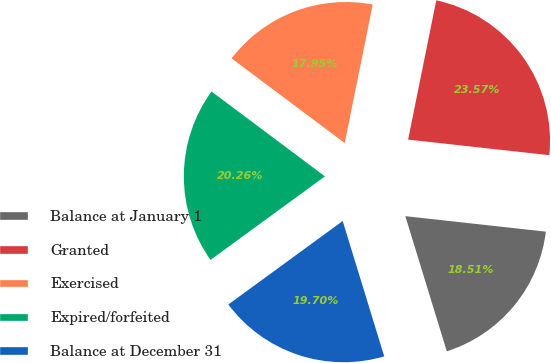<chart> <loc_0><loc_0><loc_500><loc_500><pie_chart><fcel>Balance at January 1<fcel>Granted<fcel>Exercised<fcel>Expired/forfeited<fcel>Balance at December 31<nl><fcel>18.51%<fcel>23.57%<fcel>17.95%<fcel>20.26%<fcel>19.7%<nl></chart> 